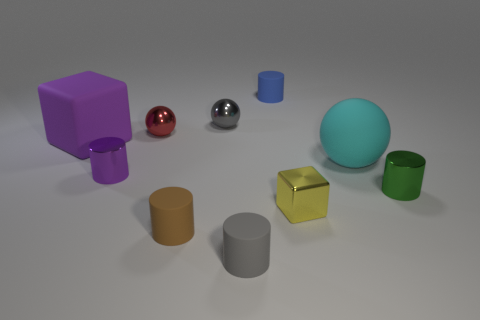Subtract all blue rubber cylinders. How many cylinders are left? 4 Subtract all blue cylinders. How many cylinders are left? 4 Subtract 2 cylinders. How many cylinders are left? 3 Subtract all yellow cylinders. Subtract all yellow cubes. How many cylinders are left? 5 Subtract all spheres. How many objects are left? 7 Add 4 yellow shiny objects. How many yellow shiny objects are left? 5 Add 5 small yellow metal cubes. How many small yellow metal cubes exist? 6 Subtract 1 red spheres. How many objects are left? 9 Subtract all tiny red objects. Subtract all red things. How many objects are left? 8 